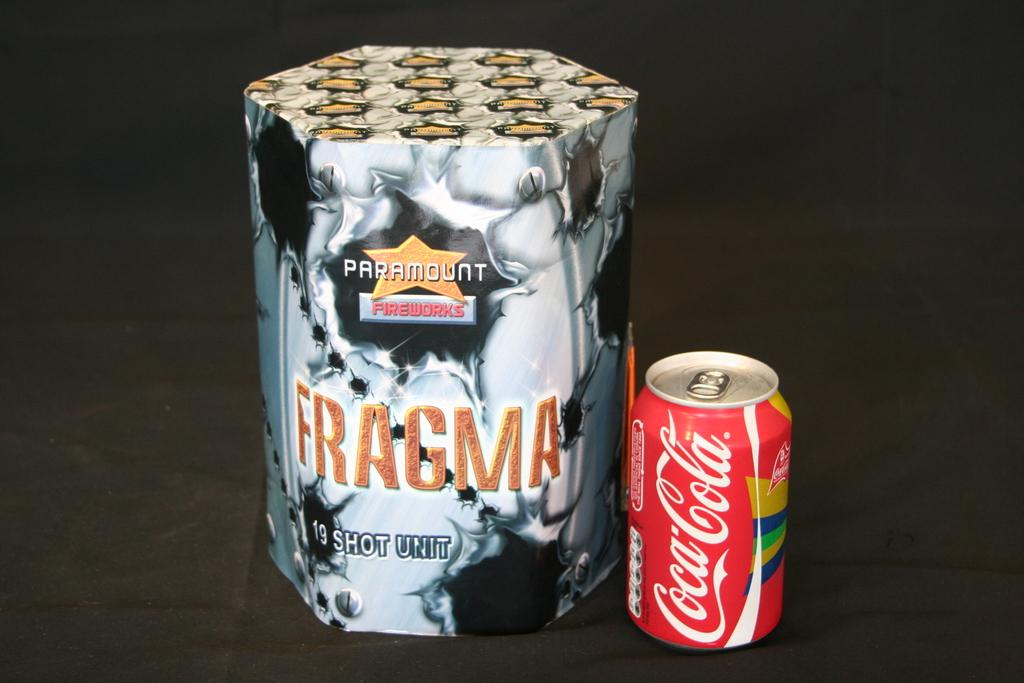<image>
Describe the image concisely. A red tin of coca cola sits beside another object with the word Fragma written on it, 